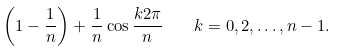Convert formula to latex. <formula><loc_0><loc_0><loc_500><loc_500>\left ( 1 - \frac { 1 } { n } \right ) + \frac { 1 } { n } \cos \frac { k 2 \pi } { n } \quad k = 0 , 2 , \dots , n - 1 .</formula> 